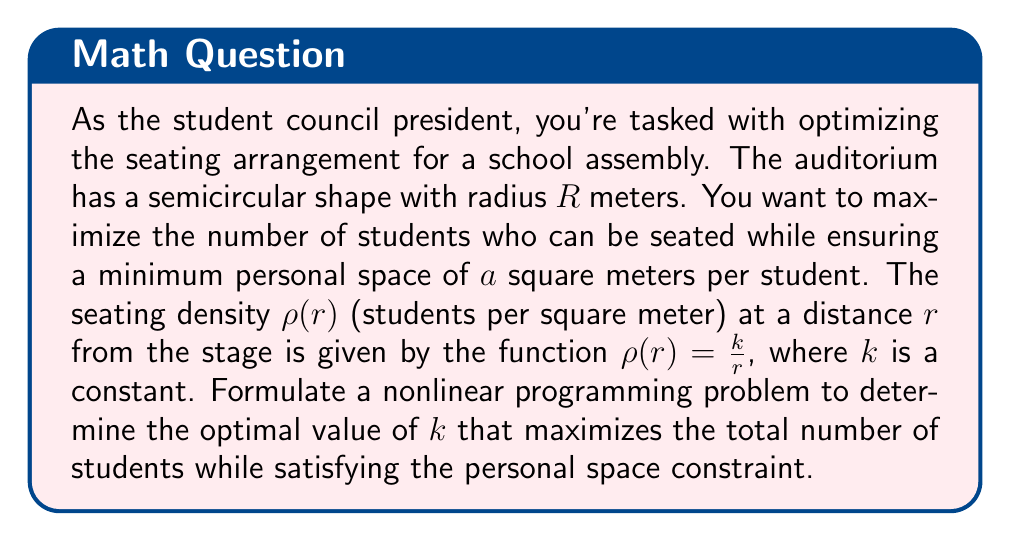Teach me how to tackle this problem. Let's approach this problem step-by-step:

1) The area of a small section at radius $r$ with width $dr$ is given by:
   $$dA = \pi r dr$$

2) The number of students in this small section is:
   $$dN = \rho(r) \cdot dA = \frac{k}{r} \cdot \pi r dr = k\pi dr$$

3) The total number of students (N) is the integral of dN from 0 to R:
   $$N = \int_0^R k\pi dr = k\pi R$$

4) This is our objective function to maximize.

5) Now, for the constraint. The personal space at radius $r$ is:
   $$\frac{1}{\rho(r)} = \frac{r}{k}$$

6) This should be greater than or equal to $a$ for all $r$:
   $$\frac{r}{k} \geq a$$

7) The most restrictive case is when $r = R$, so our constraint is:
   $$\frac{R}{k} \geq a$$
   or
   $$k \leq \frac{R}{a}$$

8) Our nonlinear programming problem is thus:

   Maximize: $$N = k\pi R$$
   Subject to: $$k \leq \frac{R}{a}$$
   $$k \geq 0$$

9) The solution to this problem is straightforward. Since N increases with k, and k is bounded above by $\frac{R}{a}$, the optimal value of k is:
   $$k_{opt} = \frac{R}{a}$$

10) The maximum number of students is therefore:
    $$N_{max} = k_{opt}\pi R = \frac{R}{a}\pi R = \frac{\pi R^2}{a}$$
Answer: $k_{opt} = \frac{R}{a}$, $N_{max} = \frac{\pi R^2}{a}$ 